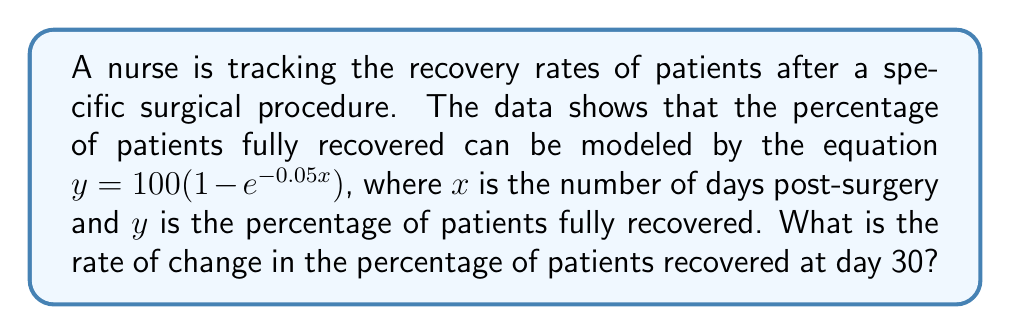Provide a solution to this math problem. To find the rate of change in the percentage of patients recovered at day 30, we need to find the derivative of the given function and evaluate it at $x = 30$.

Step 1: Given equation
$y = 100(1 - e^{-0.05x})$

Step 2: Find the derivative
$\frac{dy}{dx} = 100(-1)(e^{-0.05x})(-0.05)$
$\frac{dy}{dx} = 5e^{-0.05x}$

Step 3: Evaluate the derivative at $x = 30$
$\frac{dy}{dx}|_{x=30} = 5e^{-0.05(30)}$
$\frac{dy}{dx}|_{x=30} = 5e^{-1.5}$

Step 4: Calculate the result
$\frac{dy}{dx}|_{x=30} = 5 * 0.2231 = 1.1155$

The rate of change in the percentage of patients recovered at day 30 is approximately 1.1155% per day.
Answer: $1.1155\%$ per day 